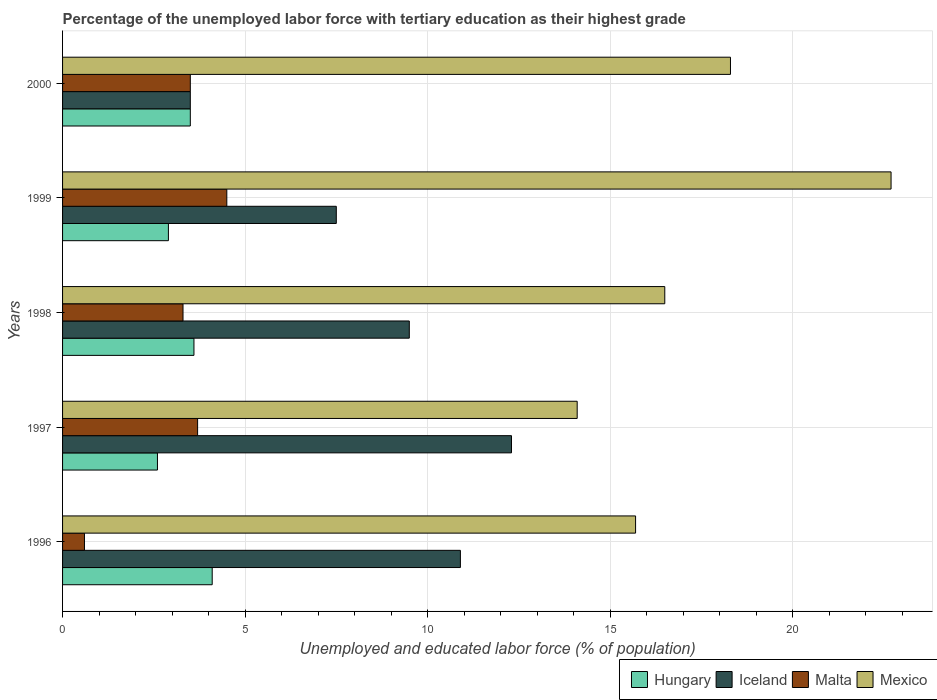How many different coloured bars are there?
Offer a terse response. 4. How many groups of bars are there?
Your answer should be very brief. 5. How many bars are there on the 3rd tick from the top?
Your response must be concise. 4. How many bars are there on the 1st tick from the bottom?
Make the answer very short. 4. In how many cases, is the number of bars for a given year not equal to the number of legend labels?
Offer a terse response. 0. What is the percentage of the unemployed labor force with tertiary education in Hungary in 1999?
Keep it short and to the point. 2.9. Across all years, what is the minimum percentage of the unemployed labor force with tertiary education in Mexico?
Ensure brevity in your answer.  14.1. In which year was the percentage of the unemployed labor force with tertiary education in Mexico maximum?
Keep it short and to the point. 1999. In which year was the percentage of the unemployed labor force with tertiary education in Mexico minimum?
Your response must be concise. 1997. What is the total percentage of the unemployed labor force with tertiary education in Mexico in the graph?
Offer a terse response. 87.3. What is the difference between the percentage of the unemployed labor force with tertiary education in Hungary in 1996 and that in 1997?
Ensure brevity in your answer.  1.5. What is the difference between the percentage of the unemployed labor force with tertiary education in Malta in 2000 and the percentage of the unemployed labor force with tertiary education in Mexico in 1999?
Provide a succinct answer. -19.2. What is the average percentage of the unemployed labor force with tertiary education in Hungary per year?
Offer a very short reply. 3.34. In the year 1999, what is the difference between the percentage of the unemployed labor force with tertiary education in Hungary and percentage of the unemployed labor force with tertiary education in Mexico?
Offer a terse response. -19.8. What is the ratio of the percentage of the unemployed labor force with tertiary education in Mexico in 1998 to that in 2000?
Your response must be concise. 0.9. Is the percentage of the unemployed labor force with tertiary education in Mexico in 1996 less than that in 1999?
Your answer should be compact. Yes. Is the difference between the percentage of the unemployed labor force with tertiary education in Hungary in 1996 and 2000 greater than the difference between the percentage of the unemployed labor force with tertiary education in Mexico in 1996 and 2000?
Offer a very short reply. Yes. What is the difference between the highest and the second highest percentage of the unemployed labor force with tertiary education in Mexico?
Your response must be concise. 4.4. What is the difference between the highest and the lowest percentage of the unemployed labor force with tertiary education in Malta?
Provide a succinct answer. 3.9. In how many years, is the percentage of the unemployed labor force with tertiary education in Hungary greater than the average percentage of the unemployed labor force with tertiary education in Hungary taken over all years?
Make the answer very short. 3. Is the sum of the percentage of the unemployed labor force with tertiary education in Mexico in 1997 and 1998 greater than the maximum percentage of the unemployed labor force with tertiary education in Iceland across all years?
Provide a short and direct response. Yes. Is it the case that in every year, the sum of the percentage of the unemployed labor force with tertiary education in Mexico and percentage of the unemployed labor force with tertiary education in Hungary is greater than the sum of percentage of the unemployed labor force with tertiary education in Malta and percentage of the unemployed labor force with tertiary education in Iceland?
Give a very brief answer. No. What does the 2nd bar from the top in 2000 represents?
Provide a succinct answer. Malta. What does the 4th bar from the bottom in 1996 represents?
Your answer should be very brief. Mexico. How many bars are there?
Offer a very short reply. 20. Are all the bars in the graph horizontal?
Your answer should be compact. Yes. How many years are there in the graph?
Make the answer very short. 5. What is the difference between two consecutive major ticks on the X-axis?
Your response must be concise. 5. Does the graph contain any zero values?
Your answer should be compact. No. How many legend labels are there?
Offer a terse response. 4. What is the title of the graph?
Keep it short and to the point. Percentage of the unemployed labor force with tertiary education as their highest grade. Does "India" appear as one of the legend labels in the graph?
Your response must be concise. No. What is the label or title of the X-axis?
Make the answer very short. Unemployed and educated labor force (% of population). What is the Unemployed and educated labor force (% of population) in Hungary in 1996?
Offer a very short reply. 4.1. What is the Unemployed and educated labor force (% of population) in Iceland in 1996?
Make the answer very short. 10.9. What is the Unemployed and educated labor force (% of population) of Malta in 1996?
Your response must be concise. 0.6. What is the Unemployed and educated labor force (% of population) in Mexico in 1996?
Your answer should be very brief. 15.7. What is the Unemployed and educated labor force (% of population) in Hungary in 1997?
Provide a short and direct response. 2.6. What is the Unemployed and educated labor force (% of population) in Iceland in 1997?
Keep it short and to the point. 12.3. What is the Unemployed and educated labor force (% of population) in Malta in 1997?
Your response must be concise. 3.7. What is the Unemployed and educated labor force (% of population) of Mexico in 1997?
Your answer should be very brief. 14.1. What is the Unemployed and educated labor force (% of population) of Hungary in 1998?
Keep it short and to the point. 3.6. What is the Unemployed and educated labor force (% of population) of Iceland in 1998?
Offer a very short reply. 9.5. What is the Unemployed and educated labor force (% of population) of Malta in 1998?
Your answer should be very brief. 3.3. What is the Unemployed and educated labor force (% of population) in Mexico in 1998?
Provide a succinct answer. 16.5. What is the Unemployed and educated labor force (% of population) of Hungary in 1999?
Offer a very short reply. 2.9. What is the Unemployed and educated labor force (% of population) of Iceland in 1999?
Make the answer very short. 7.5. What is the Unemployed and educated labor force (% of population) of Malta in 1999?
Offer a terse response. 4.5. What is the Unemployed and educated labor force (% of population) in Mexico in 1999?
Make the answer very short. 22.7. What is the Unemployed and educated labor force (% of population) in Mexico in 2000?
Your answer should be compact. 18.3. Across all years, what is the maximum Unemployed and educated labor force (% of population) of Hungary?
Provide a succinct answer. 4.1. Across all years, what is the maximum Unemployed and educated labor force (% of population) of Iceland?
Your answer should be very brief. 12.3. Across all years, what is the maximum Unemployed and educated labor force (% of population) of Mexico?
Give a very brief answer. 22.7. Across all years, what is the minimum Unemployed and educated labor force (% of population) of Hungary?
Keep it short and to the point. 2.6. Across all years, what is the minimum Unemployed and educated labor force (% of population) in Malta?
Provide a short and direct response. 0.6. Across all years, what is the minimum Unemployed and educated labor force (% of population) in Mexico?
Keep it short and to the point. 14.1. What is the total Unemployed and educated labor force (% of population) of Iceland in the graph?
Your answer should be very brief. 43.7. What is the total Unemployed and educated labor force (% of population) in Malta in the graph?
Your answer should be compact. 15.6. What is the total Unemployed and educated labor force (% of population) of Mexico in the graph?
Offer a very short reply. 87.3. What is the difference between the Unemployed and educated labor force (% of population) of Iceland in 1996 and that in 1997?
Offer a very short reply. -1.4. What is the difference between the Unemployed and educated labor force (% of population) in Mexico in 1996 and that in 1997?
Offer a very short reply. 1.6. What is the difference between the Unemployed and educated labor force (% of population) in Malta in 1996 and that in 1998?
Keep it short and to the point. -2.7. What is the difference between the Unemployed and educated labor force (% of population) in Iceland in 1996 and that in 1999?
Ensure brevity in your answer.  3.4. What is the difference between the Unemployed and educated labor force (% of population) of Malta in 1996 and that in 1999?
Ensure brevity in your answer.  -3.9. What is the difference between the Unemployed and educated labor force (% of population) of Mexico in 1996 and that in 2000?
Your answer should be very brief. -2.6. What is the difference between the Unemployed and educated labor force (% of population) of Iceland in 1997 and that in 1998?
Provide a short and direct response. 2.8. What is the difference between the Unemployed and educated labor force (% of population) of Malta in 1997 and that in 1998?
Offer a very short reply. 0.4. What is the difference between the Unemployed and educated labor force (% of population) of Hungary in 1997 and that in 1999?
Provide a short and direct response. -0.3. What is the difference between the Unemployed and educated labor force (% of population) in Mexico in 1997 and that in 1999?
Provide a short and direct response. -8.6. What is the difference between the Unemployed and educated labor force (% of population) in Hungary in 1997 and that in 2000?
Make the answer very short. -0.9. What is the difference between the Unemployed and educated labor force (% of population) of Iceland in 1997 and that in 2000?
Provide a short and direct response. 8.8. What is the difference between the Unemployed and educated labor force (% of population) in Malta in 1998 and that in 1999?
Your answer should be very brief. -1.2. What is the difference between the Unemployed and educated labor force (% of population) of Mexico in 1998 and that in 1999?
Keep it short and to the point. -6.2. What is the difference between the Unemployed and educated labor force (% of population) in Hungary in 1998 and that in 2000?
Ensure brevity in your answer.  0.1. What is the difference between the Unemployed and educated labor force (% of population) of Malta in 1998 and that in 2000?
Your response must be concise. -0.2. What is the difference between the Unemployed and educated labor force (% of population) in Malta in 1999 and that in 2000?
Provide a short and direct response. 1. What is the difference between the Unemployed and educated labor force (% of population) in Mexico in 1999 and that in 2000?
Keep it short and to the point. 4.4. What is the difference between the Unemployed and educated labor force (% of population) in Hungary in 1996 and the Unemployed and educated labor force (% of population) in Iceland in 1997?
Your response must be concise. -8.2. What is the difference between the Unemployed and educated labor force (% of population) of Hungary in 1996 and the Unemployed and educated labor force (% of population) of Mexico in 1997?
Your answer should be compact. -10. What is the difference between the Unemployed and educated labor force (% of population) in Malta in 1996 and the Unemployed and educated labor force (% of population) in Mexico in 1997?
Provide a short and direct response. -13.5. What is the difference between the Unemployed and educated labor force (% of population) in Iceland in 1996 and the Unemployed and educated labor force (% of population) in Malta in 1998?
Ensure brevity in your answer.  7.6. What is the difference between the Unemployed and educated labor force (% of population) of Iceland in 1996 and the Unemployed and educated labor force (% of population) of Mexico in 1998?
Offer a very short reply. -5.6. What is the difference between the Unemployed and educated labor force (% of population) in Malta in 1996 and the Unemployed and educated labor force (% of population) in Mexico in 1998?
Offer a terse response. -15.9. What is the difference between the Unemployed and educated labor force (% of population) in Hungary in 1996 and the Unemployed and educated labor force (% of population) in Iceland in 1999?
Your answer should be compact. -3.4. What is the difference between the Unemployed and educated labor force (% of population) in Hungary in 1996 and the Unemployed and educated labor force (% of population) in Malta in 1999?
Give a very brief answer. -0.4. What is the difference between the Unemployed and educated labor force (% of population) in Hungary in 1996 and the Unemployed and educated labor force (% of population) in Mexico in 1999?
Your answer should be very brief. -18.6. What is the difference between the Unemployed and educated labor force (% of population) of Iceland in 1996 and the Unemployed and educated labor force (% of population) of Malta in 1999?
Your answer should be compact. 6.4. What is the difference between the Unemployed and educated labor force (% of population) in Malta in 1996 and the Unemployed and educated labor force (% of population) in Mexico in 1999?
Provide a short and direct response. -22.1. What is the difference between the Unemployed and educated labor force (% of population) of Hungary in 1996 and the Unemployed and educated labor force (% of population) of Iceland in 2000?
Keep it short and to the point. 0.6. What is the difference between the Unemployed and educated labor force (% of population) in Hungary in 1996 and the Unemployed and educated labor force (% of population) in Malta in 2000?
Your response must be concise. 0.6. What is the difference between the Unemployed and educated labor force (% of population) of Malta in 1996 and the Unemployed and educated labor force (% of population) of Mexico in 2000?
Give a very brief answer. -17.7. What is the difference between the Unemployed and educated labor force (% of population) in Hungary in 1997 and the Unemployed and educated labor force (% of population) in Iceland in 1998?
Your answer should be very brief. -6.9. What is the difference between the Unemployed and educated labor force (% of population) in Hungary in 1997 and the Unemployed and educated labor force (% of population) in Malta in 1998?
Provide a succinct answer. -0.7. What is the difference between the Unemployed and educated labor force (% of population) in Iceland in 1997 and the Unemployed and educated labor force (% of population) in Malta in 1998?
Keep it short and to the point. 9. What is the difference between the Unemployed and educated labor force (% of population) in Iceland in 1997 and the Unemployed and educated labor force (% of population) in Mexico in 1998?
Offer a very short reply. -4.2. What is the difference between the Unemployed and educated labor force (% of population) in Hungary in 1997 and the Unemployed and educated labor force (% of population) in Iceland in 1999?
Ensure brevity in your answer.  -4.9. What is the difference between the Unemployed and educated labor force (% of population) in Hungary in 1997 and the Unemployed and educated labor force (% of population) in Malta in 1999?
Provide a succinct answer. -1.9. What is the difference between the Unemployed and educated labor force (% of population) of Hungary in 1997 and the Unemployed and educated labor force (% of population) of Mexico in 1999?
Your response must be concise. -20.1. What is the difference between the Unemployed and educated labor force (% of population) in Malta in 1997 and the Unemployed and educated labor force (% of population) in Mexico in 1999?
Make the answer very short. -19. What is the difference between the Unemployed and educated labor force (% of population) of Hungary in 1997 and the Unemployed and educated labor force (% of population) of Mexico in 2000?
Offer a very short reply. -15.7. What is the difference between the Unemployed and educated labor force (% of population) of Iceland in 1997 and the Unemployed and educated labor force (% of population) of Malta in 2000?
Your response must be concise. 8.8. What is the difference between the Unemployed and educated labor force (% of population) of Iceland in 1997 and the Unemployed and educated labor force (% of population) of Mexico in 2000?
Offer a very short reply. -6. What is the difference between the Unemployed and educated labor force (% of population) in Malta in 1997 and the Unemployed and educated labor force (% of population) in Mexico in 2000?
Ensure brevity in your answer.  -14.6. What is the difference between the Unemployed and educated labor force (% of population) in Hungary in 1998 and the Unemployed and educated labor force (% of population) in Malta in 1999?
Keep it short and to the point. -0.9. What is the difference between the Unemployed and educated labor force (% of population) in Hungary in 1998 and the Unemployed and educated labor force (% of population) in Mexico in 1999?
Offer a terse response. -19.1. What is the difference between the Unemployed and educated labor force (% of population) in Iceland in 1998 and the Unemployed and educated labor force (% of population) in Mexico in 1999?
Your response must be concise. -13.2. What is the difference between the Unemployed and educated labor force (% of population) in Malta in 1998 and the Unemployed and educated labor force (% of population) in Mexico in 1999?
Your response must be concise. -19.4. What is the difference between the Unemployed and educated labor force (% of population) in Hungary in 1998 and the Unemployed and educated labor force (% of population) in Mexico in 2000?
Keep it short and to the point. -14.7. What is the difference between the Unemployed and educated labor force (% of population) of Iceland in 1998 and the Unemployed and educated labor force (% of population) of Malta in 2000?
Provide a short and direct response. 6. What is the difference between the Unemployed and educated labor force (% of population) in Malta in 1998 and the Unemployed and educated labor force (% of population) in Mexico in 2000?
Keep it short and to the point. -15. What is the difference between the Unemployed and educated labor force (% of population) of Hungary in 1999 and the Unemployed and educated labor force (% of population) of Mexico in 2000?
Provide a short and direct response. -15.4. What is the difference between the Unemployed and educated labor force (% of population) in Malta in 1999 and the Unemployed and educated labor force (% of population) in Mexico in 2000?
Your answer should be compact. -13.8. What is the average Unemployed and educated labor force (% of population) of Hungary per year?
Your answer should be compact. 3.34. What is the average Unemployed and educated labor force (% of population) of Iceland per year?
Provide a succinct answer. 8.74. What is the average Unemployed and educated labor force (% of population) of Malta per year?
Provide a succinct answer. 3.12. What is the average Unemployed and educated labor force (% of population) of Mexico per year?
Your response must be concise. 17.46. In the year 1996, what is the difference between the Unemployed and educated labor force (% of population) in Hungary and Unemployed and educated labor force (% of population) in Iceland?
Provide a succinct answer. -6.8. In the year 1996, what is the difference between the Unemployed and educated labor force (% of population) in Hungary and Unemployed and educated labor force (% of population) in Malta?
Offer a very short reply. 3.5. In the year 1996, what is the difference between the Unemployed and educated labor force (% of population) in Hungary and Unemployed and educated labor force (% of population) in Mexico?
Your response must be concise. -11.6. In the year 1996, what is the difference between the Unemployed and educated labor force (% of population) of Iceland and Unemployed and educated labor force (% of population) of Malta?
Make the answer very short. 10.3. In the year 1996, what is the difference between the Unemployed and educated labor force (% of population) of Iceland and Unemployed and educated labor force (% of population) of Mexico?
Provide a short and direct response. -4.8. In the year 1996, what is the difference between the Unemployed and educated labor force (% of population) of Malta and Unemployed and educated labor force (% of population) of Mexico?
Ensure brevity in your answer.  -15.1. In the year 1997, what is the difference between the Unemployed and educated labor force (% of population) in Hungary and Unemployed and educated labor force (% of population) in Iceland?
Ensure brevity in your answer.  -9.7. In the year 1997, what is the difference between the Unemployed and educated labor force (% of population) of Hungary and Unemployed and educated labor force (% of population) of Malta?
Provide a succinct answer. -1.1. In the year 1997, what is the difference between the Unemployed and educated labor force (% of population) in Hungary and Unemployed and educated labor force (% of population) in Mexico?
Your response must be concise. -11.5. In the year 1997, what is the difference between the Unemployed and educated labor force (% of population) of Iceland and Unemployed and educated labor force (% of population) of Malta?
Your answer should be very brief. 8.6. In the year 1997, what is the difference between the Unemployed and educated labor force (% of population) of Malta and Unemployed and educated labor force (% of population) of Mexico?
Ensure brevity in your answer.  -10.4. In the year 1998, what is the difference between the Unemployed and educated labor force (% of population) in Hungary and Unemployed and educated labor force (% of population) in Malta?
Ensure brevity in your answer.  0.3. In the year 1999, what is the difference between the Unemployed and educated labor force (% of population) in Hungary and Unemployed and educated labor force (% of population) in Iceland?
Your answer should be compact. -4.6. In the year 1999, what is the difference between the Unemployed and educated labor force (% of population) in Hungary and Unemployed and educated labor force (% of population) in Malta?
Keep it short and to the point. -1.6. In the year 1999, what is the difference between the Unemployed and educated labor force (% of population) of Hungary and Unemployed and educated labor force (% of population) of Mexico?
Your answer should be compact. -19.8. In the year 1999, what is the difference between the Unemployed and educated labor force (% of population) of Iceland and Unemployed and educated labor force (% of population) of Mexico?
Provide a short and direct response. -15.2. In the year 1999, what is the difference between the Unemployed and educated labor force (% of population) of Malta and Unemployed and educated labor force (% of population) of Mexico?
Keep it short and to the point. -18.2. In the year 2000, what is the difference between the Unemployed and educated labor force (% of population) of Hungary and Unemployed and educated labor force (% of population) of Mexico?
Provide a short and direct response. -14.8. In the year 2000, what is the difference between the Unemployed and educated labor force (% of population) in Iceland and Unemployed and educated labor force (% of population) in Mexico?
Ensure brevity in your answer.  -14.8. In the year 2000, what is the difference between the Unemployed and educated labor force (% of population) of Malta and Unemployed and educated labor force (% of population) of Mexico?
Keep it short and to the point. -14.8. What is the ratio of the Unemployed and educated labor force (% of population) of Hungary in 1996 to that in 1997?
Offer a terse response. 1.58. What is the ratio of the Unemployed and educated labor force (% of population) of Iceland in 1996 to that in 1997?
Offer a terse response. 0.89. What is the ratio of the Unemployed and educated labor force (% of population) of Malta in 1996 to that in 1997?
Give a very brief answer. 0.16. What is the ratio of the Unemployed and educated labor force (% of population) in Mexico in 1996 to that in 1997?
Your response must be concise. 1.11. What is the ratio of the Unemployed and educated labor force (% of population) of Hungary in 1996 to that in 1998?
Your response must be concise. 1.14. What is the ratio of the Unemployed and educated labor force (% of population) of Iceland in 1996 to that in 1998?
Provide a short and direct response. 1.15. What is the ratio of the Unemployed and educated labor force (% of population) of Malta in 1996 to that in 1998?
Keep it short and to the point. 0.18. What is the ratio of the Unemployed and educated labor force (% of population) of Mexico in 1996 to that in 1998?
Ensure brevity in your answer.  0.95. What is the ratio of the Unemployed and educated labor force (% of population) of Hungary in 1996 to that in 1999?
Offer a terse response. 1.41. What is the ratio of the Unemployed and educated labor force (% of population) of Iceland in 1996 to that in 1999?
Offer a very short reply. 1.45. What is the ratio of the Unemployed and educated labor force (% of population) in Malta in 1996 to that in 1999?
Your response must be concise. 0.13. What is the ratio of the Unemployed and educated labor force (% of population) in Mexico in 1996 to that in 1999?
Offer a terse response. 0.69. What is the ratio of the Unemployed and educated labor force (% of population) of Hungary in 1996 to that in 2000?
Offer a terse response. 1.17. What is the ratio of the Unemployed and educated labor force (% of population) in Iceland in 1996 to that in 2000?
Ensure brevity in your answer.  3.11. What is the ratio of the Unemployed and educated labor force (% of population) of Malta in 1996 to that in 2000?
Ensure brevity in your answer.  0.17. What is the ratio of the Unemployed and educated labor force (% of population) in Mexico in 1996 to that in 2000?
Offer a terse response. 0.86. What is the ratio of the Unemployed and educated labor force (% of population) of Hungary in 1997 to that in 1998?
Ensure brevity in your answer.  0.72. What is the ratio of the Unemployed and educated labor force (% of population) in Iceland in 1997 to that in 1998?
Make the answer very short. 1.29. What is the ratio of the Unemployed and educated labor force (% of population) in Malta in 1997 to that in 1998?
Give a very brief answer. 1.12. What is the ratio of the Unemployed and educated labor force (% of population) in Mexico in 1997 to that in 1998?
Provide a short and direct response. 0.85. What is the ratio of the Unemployed and educated labor force (% of population) in Hungary in 1997 to that in 1999?
Give a very brief answer. 0.9. What is the ratio of the Unemployed and educated labor force (% of population) in Iceland in 1997 to that in 1999?
Offer a terse response. 1.64. What is the ratio of the Unemployed and educated labor force (% of population) in Malta in 1997 to that in 1999?
Keep it short and to the point. 0.82. What is the ratio of the Unemployed and educated labor force (% of population) in Mexico in 1997 to that in 1999?
Offer a very short reply. 0.62. What is the ratio of the Unemployed and educated labor force (% of population) in Hungary in 1997 to that in 2000?
Your response must be concise. 0.74. What is the ratio of the Unemployed and educated labor force (% of population) in Iceland in 1997 to that in 2000?
Your response must be concise. 3.51. What is the ratio of the Unemployed and educated labor force (% of population) of Malta in 1997 to that in 2000?
Ensure brevity in your answer.  1.06. What is the ratio of the Unemployed and educated labor force (% of population) in Mexico in 1997 to that in 2000?
Offer a very short reply. 0.77. What is the ratio of the Unemployed and educated labor force (% of population) in Hungary in 1998 to that in 1999?
Give a very brief answer. 1.24. What is the ratio of the Unemployed and educated labor force (% of population) of Iceland in 1998 to that in 1999?
Provide a short and direct response. 1.27. What is the ratio of the Unemployed and educated labor force (% of population) in Malta in 1998 to that in 1999?
Your response must be concise. 0.73. What is the ratio of the Unemployed and educated labor force (% of population) of Mexico in 1998 to that in 1999?
Offer a terse response. 0.73. What is the ratio of the Unemployed and educated labor force (% of population) of Hungary in 1998 to that in 2000?
Ensure brevity in your answer.  1.03. What is the ratio of the Unemployed and educated labor force (% of population) in Iceland in 1998 to that in 2000?
Your answer should be compact. 2.71. What is the ratio of the Unemployed and educated labor force (% of population) of Malta in 1998 to that in 2000?
Keep it short and to the point. 0.94. What is the ratio of the Unemployed and educated labor force (% of population) of Mexico in 1998 to that in 2000?
Provide a succinct answer. 0.9. What is the ratio of the Unemployed and educated labor force (% of population) in Hungary in 1999 to that in 2000?
Offer a very short reply. 0.83. What is the ratio of the Unemployed and educated labor force (% of population) of Iceland in 1999 to that in 2000?
Give a very brief answer. 2.14. What is the ratio of the Unemployed and educated labor force (% of population) of Mexico in 1999 to that in 2000?
Offer a very short reply. 1.24. What is the difference between the highest and the second highest Unemployed and educated labor force (% of population) of Malta?
Your answer should be very brief. 0.8. What is the difference between the highest and the second highest Unemployed and educated labor force (% of population) of Mexico?
Offer a terse response. 4.4. What is the difference between the highest and the lowest Unemployed and educated labor force (% of population) in Iceland?
Make the answer very short. 8.8. What is the difference between the highest and the lowest Unemployed and educated labor force (% of population) in Mexico?
Provide a short and direct response. 8.6. 